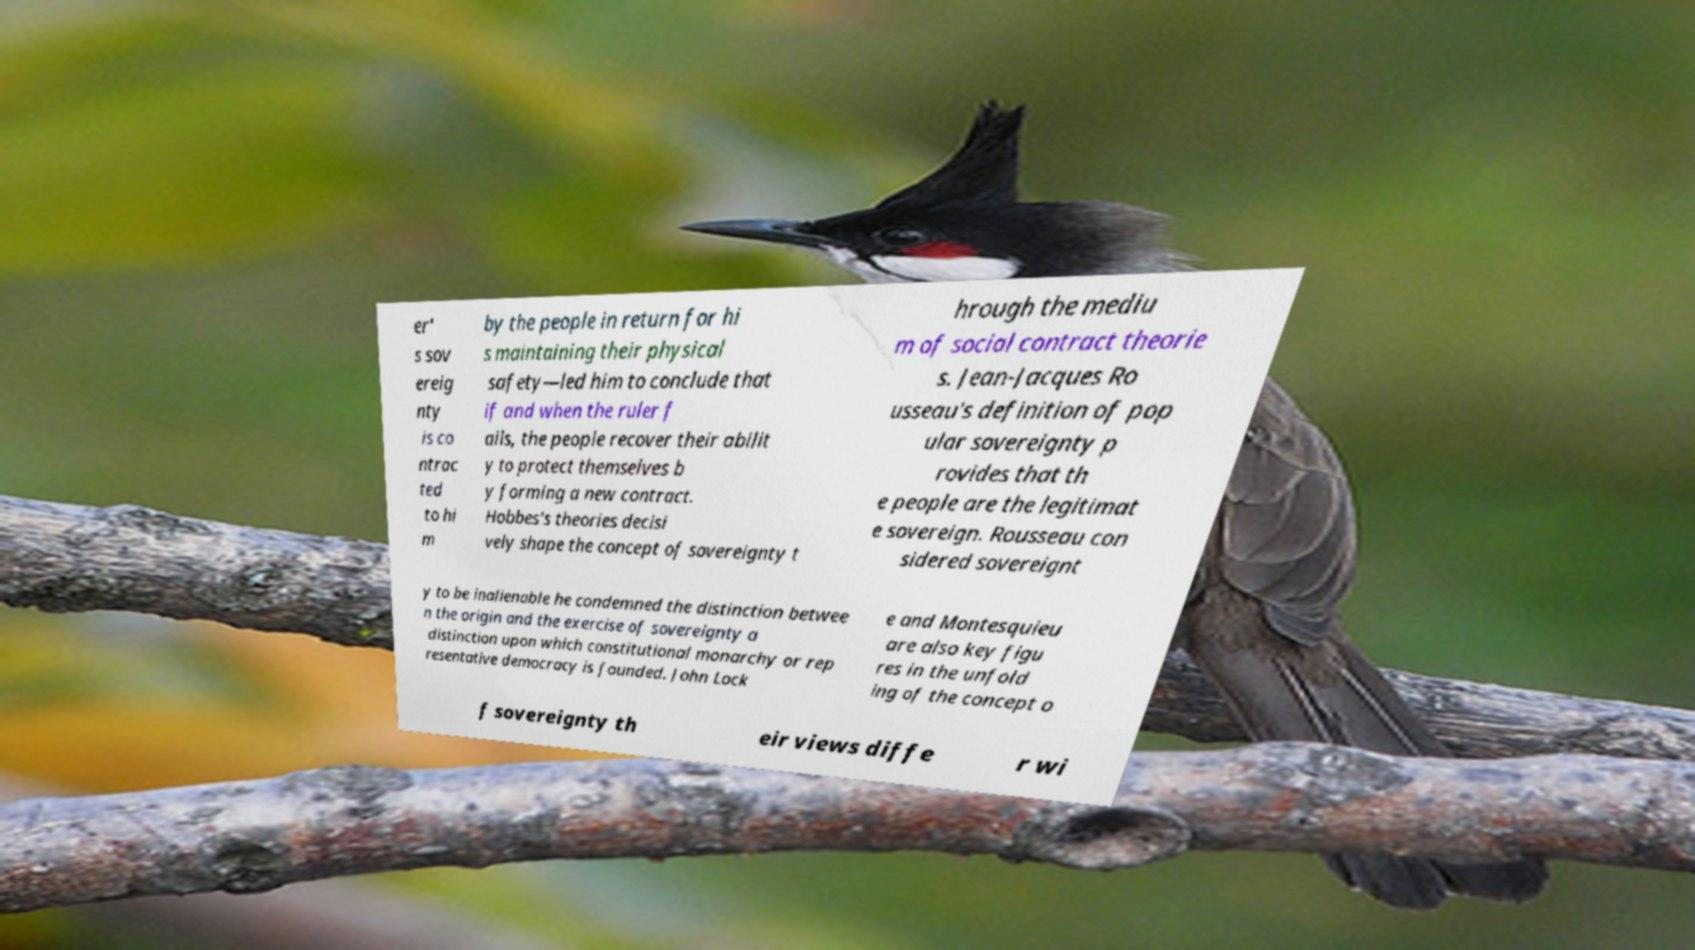Please identify and transcribe the text found in this image. er' s sov ereig nty is co ntrac ted to hi m by the people in return for hi s maintaining their physical safety—led him to conclude that if and when the ruler f ails, the people recover their abilit y to protect themselves b y forming a new contract. Hobbes's theories decisi vely shape the concept of sovereignty t hrough the mediu m of social contract theorie s. Jean-Jacques Ro usseau's definition of pop ular sovereignty p rovides that th e people are the legitimat e sovereign. Rousseau con sidered sovereignt y to be inalienable he condemned the distinction betwee n the origin and the exercise of sovereignty a distinction upon which constitutional monarchy or rep resentative democracy is founded. John Lock e and Montesquieu are also key figu res in the unfold ing of the concept o f sovereignty th eir views diffe r wi 